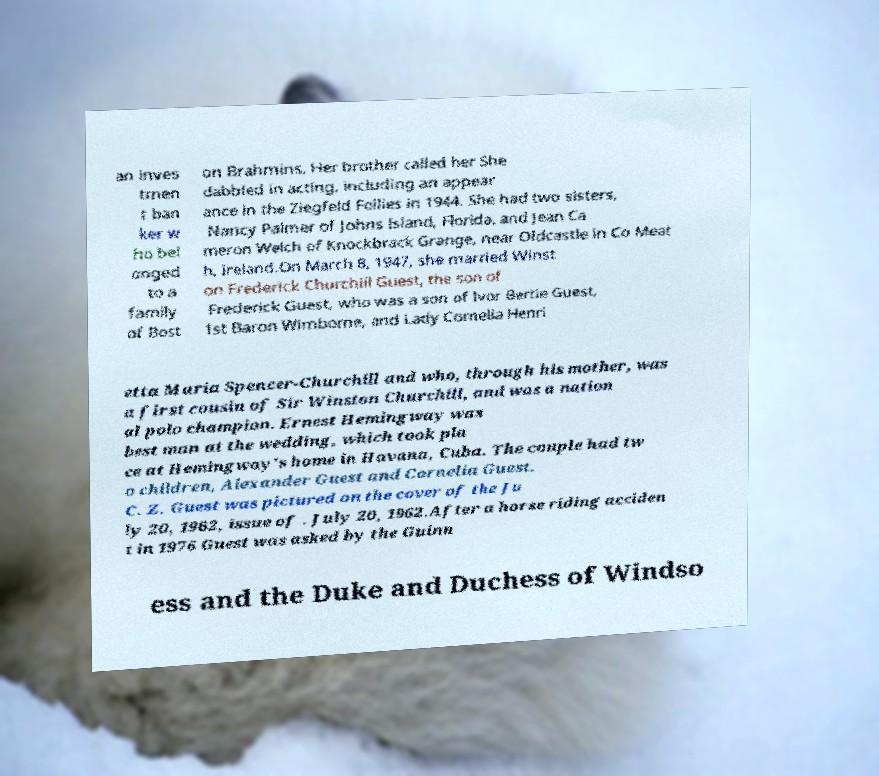I need the written content from this picture converted into text. Can you do that? an inves tmen t ban ker w ho bel onged to a family of Bost on Brahmins. Her brother called her She dabbled in acting, including an appear ance in the Ziegfeld Follies in 1944. She had two sisters, Nancy Palmer of Johns Island, Florida, and Jean Ca meron Welch of Knockbrack Grange, near Oldcastle in Co Meat h, Ireland.On March 8, 1947, she married Winst on Frederick Churchill Guest, the son of Frederick Guest, who was a son of Ivor Bertie Guest, 1st Baron Wimborne, and Lady Cornelia Henri etta Maria Spencer-Churchill and who, through his mother, was a first cousin of Sir Winston Churchill, and was a nation al polo champion. Ernest Hemingway was best man at the wedding, which took pla ce at Hemingway's home in Havana, Cuba. The couple had tw o children, Alexander Guest and Cornelia Guest. C. Z. Guest was pictured on the cover of the Ju ly 20, 1962, issue of . July 20, 1962.After a horse riding acciden t in 1976 Guest was asked by the Guinn ess and the Duke and Duchess of Windso 